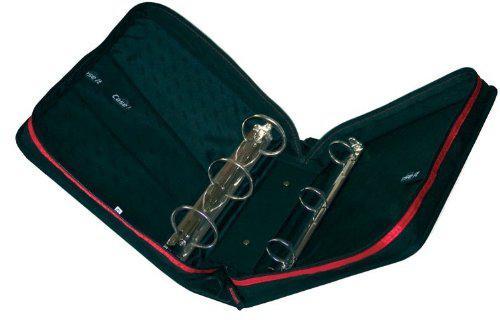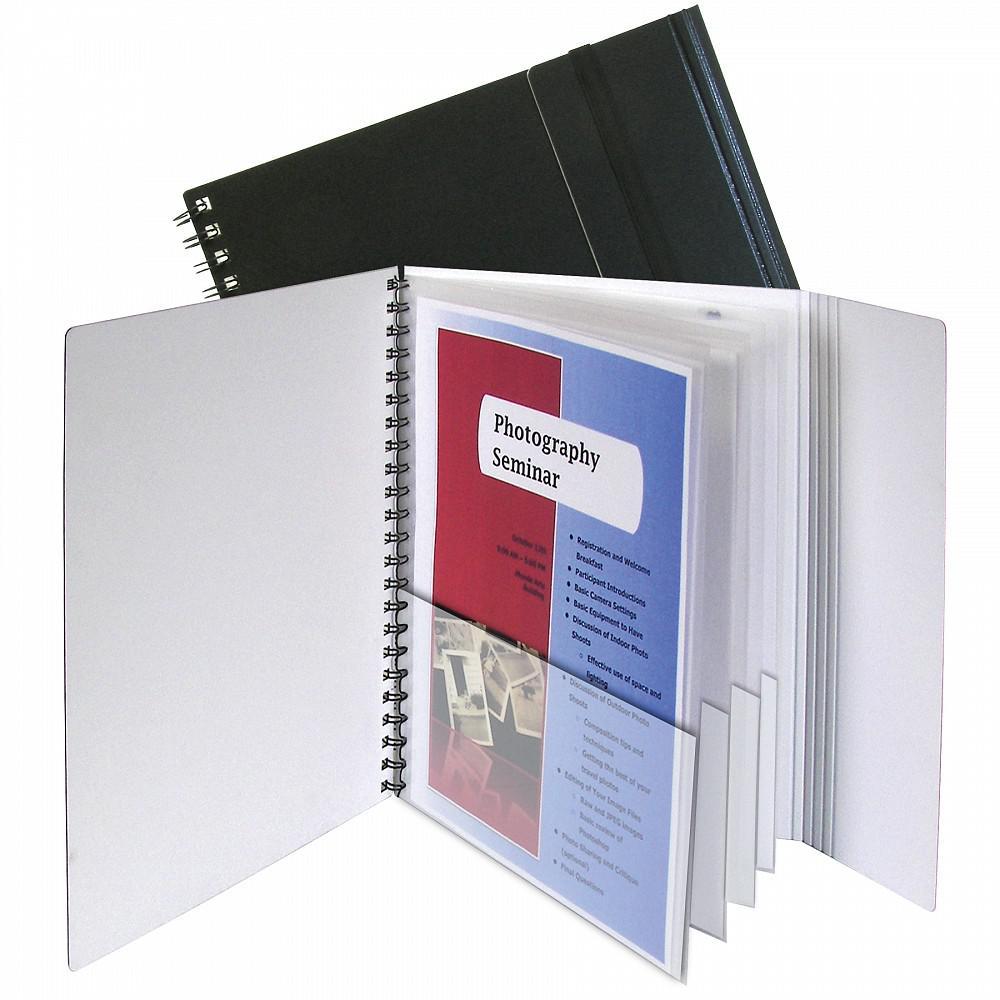The first image is the image on the left, the second image is the image on the right. Given the left and right images, does the statement "One zipper binder is unzipped and open so that at least one set of three notebook rings and multiple interior pockets are visible." hold true? Answer yes or no. Yes. The first image is the image on the left, the second image is the image on the right. For the images displayed, is the sentence "The left image shows only one binder, which is purplish in color." factually correct? Answer yes or no. No. 